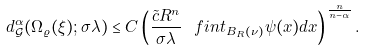<formula> <loc_0><loc_0><loc_500><loc_500>d _ { \mathcal { G } } ^ { \alpha } ( \Omega _ { \varrho } ( \xi ) ; \sigma \lambda ) \leq C \left ( \frac { \tilde { c } R ^ { n } } { \sigma \lambda } \ f i n t _ { B _ { R } ( \nu ) } \psi ( x ) d x \right ) ^ { \frac { n } { n - \alpha } } .</formula> 